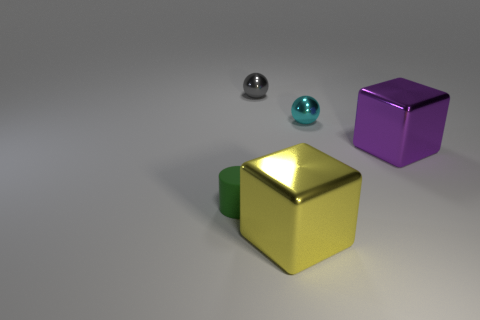Are there more tiny things than green matte spheres?
Offer a very short reply. Yes. How many objects are big things in front of the rubber cylinder or large green rubber objects?
Offer a terse response. 1. How many green objects are in front of the block that is behind the small green cylinder?
Your answer should be very brief. 1. There is a block that is left of the cube behind the shiny cube that is in front of the purple metal block; how big is it?
Offer a very short reply. Large. There is a large block on the right side of the cyan metal object; is its color the same as the small cylinder?
Keep it short and to the point. No. What size is the other shiny thing that is the same shape as the yellow thing?
Provide a short and direct response. Large. What number of objects are large cubes on the right side of the big yellow block or large cubes behind the green matte thing?
Give a very brief answer. 1. What shape is the large thing that is to the left of the sphere in front of the gray metal thing?
Ensure brevity in your answer.  Cube. Is there anything else that is the same color as the small matte cylinder?
Offer a terse response. No. Are there any other things that are the same size as the gray object?
Offer a terse response. Yes. 